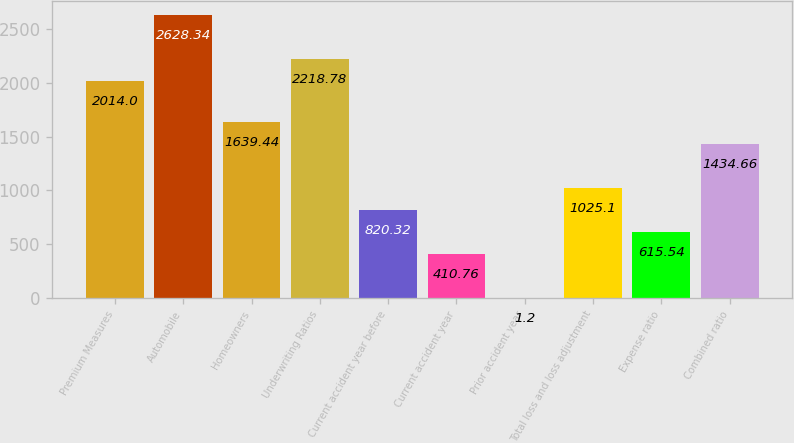<chart> <loc_0><loc_0><loc_500><loc_500><bar_chart><fcel>Premium Measures<fcel>Automobile<fcel>Homeowners<fcel>Underwriting Ratios<fcel>Current accident year before<fcel>Current accident year<fcel>Prior accident year<fcel>Total loss and loss adjustment<fcel>Expense ratio<fcel>Combined ratio<nl><fcel>2014<fcel>2628.34<fcel>1639.44<fcel>2218.78<fcel>820.32<fcel>410.76<fcel>1.2<fcel>1025.1<fcel>615.54<fcel>1434.66<nl></chart> 